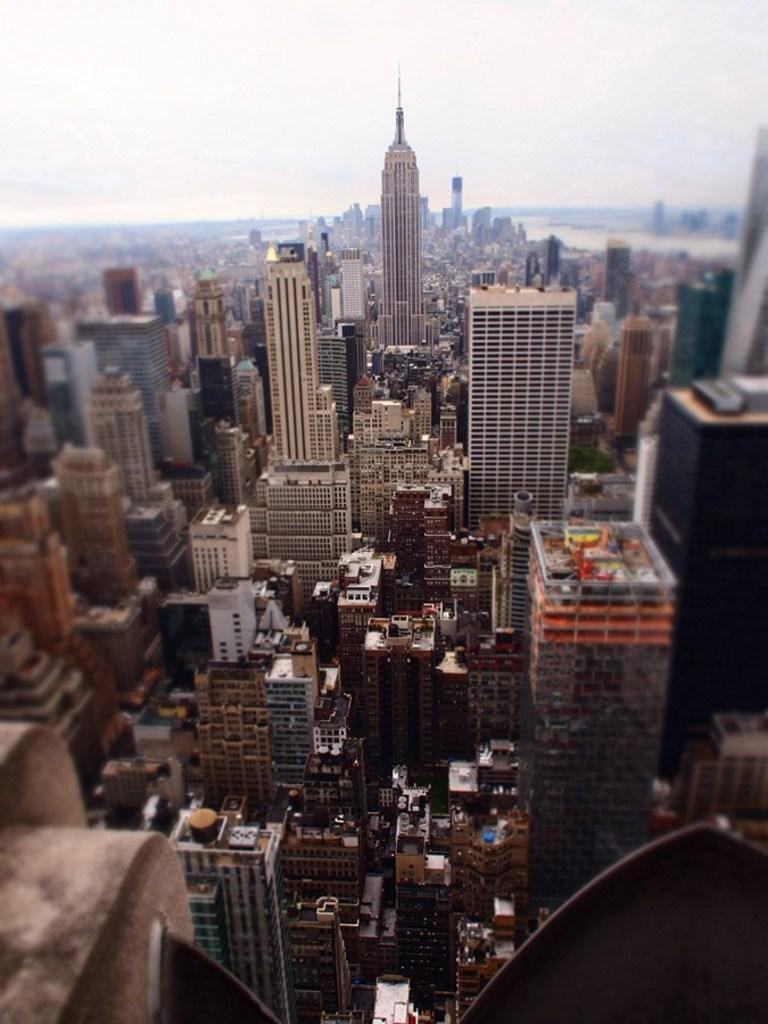Please provide a concise description of this image. In this picture we can see city. Here we can see skyscraper. On the bottom we can see buildings. Here we can see water. On the top we can see sky and clouds. 